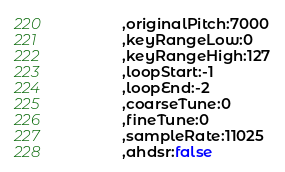Convert code to text. <code><loc_0><loc_0><loc_500><loc_500><_JavaScript_>			,originalPitch:7000
			,keyRangeLow:0
			,keyRangeHigh:127
			,loopStart:-1
			,loopEnd:-2
			,coarseTune:0
			,fineTune:0
			,sampleRate:11025
			,ahdsr:false</code> 